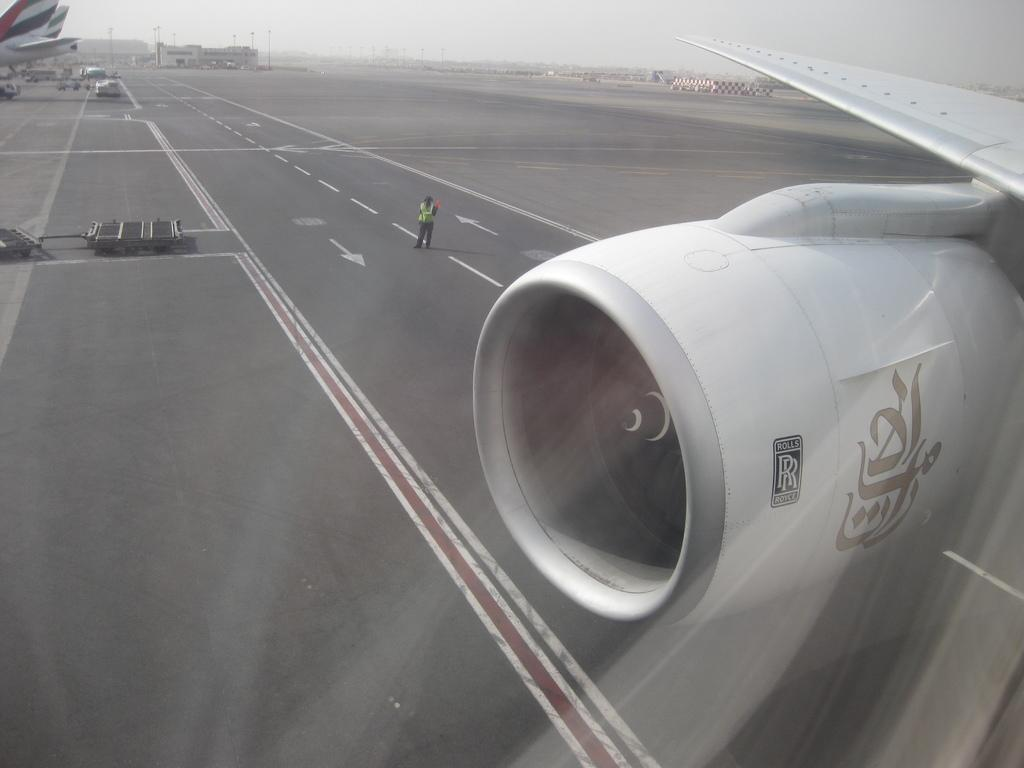What is the main subject of the image? The main subject of the image is a part of an airplane. Can you describe the setting of the image? There is a person standing on the road in the image. What can be seen in the background of the image? The sky is visible in the background of the image. What type of paste is being used by the person standing on the road in the image? There is no paste present in the image, and the person standing on the road is not using any paste. 